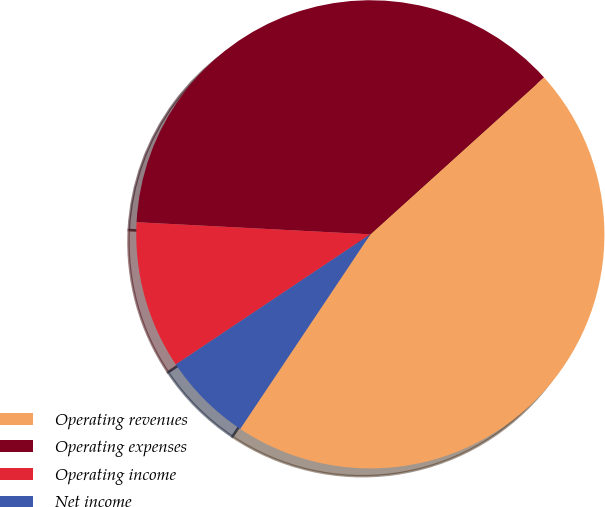Convert chart to OTSL. <chart><loc_0><loc_0><loc_500><loc_500><pie_chart><fcel>Operating revenues<fcel>Operating expenses<fcel>Operating income<fcel>Net income<nl><fcel>46.08%<fcel>37.48%<fcel>10.21%<fcel>6.23%<nl></chart> 